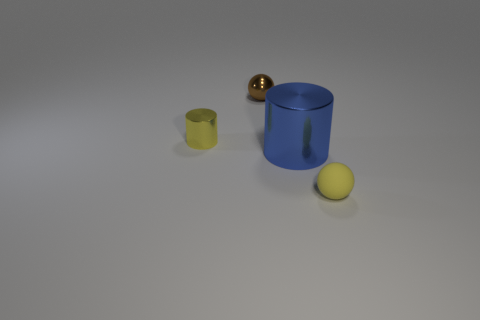Add 1 brown matte balls. How many objects exist? 5 Add 2 small gray shiny cubes. How many small gray shiny cubes exist? 2 Subtract 0 purple blocks. How many objects are left? 4 Subtract all big blue cylinders. Subtract all small gray metallic cubes. How many objects are left? 3 Add 2 big shiny cylinders. How many big shiny cylinders are left? 3 